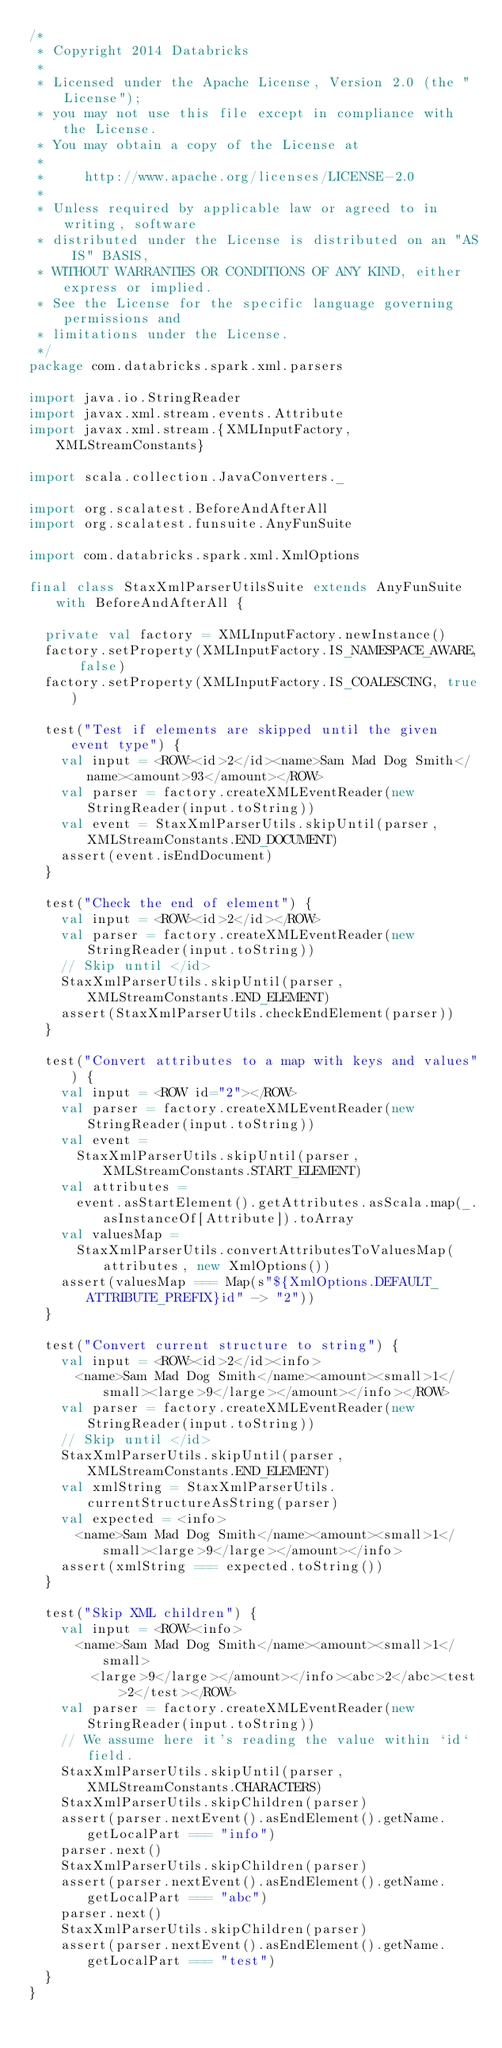Convert code to text. <code><loc_0><loc_0><loc_500><loc_500><_Scala_>/*
 * Copyright 2014 Databricks
 *
 * Licensed under the Apache License, Version 2.0 (the "License");
 * you may not use this file except in compliance with the License.
 * You may obtain a copy of the License at
 *
 *     http://www.apache.org/licenses/LICENSE-2.0
 *
 * Unless required by applicable law or agreed to in writing, software
 * distributed under the License is distributed on an "AS IS" BASIS,
 * WITHOUT WARRANTIES OR CONDITIONS OF ANY KIND, either express or implied.
 * See the License for the specific language governing permissions and
 * limitations under the License.
 */
package com.databricks.spark.xml.parsers

import java.io.StringReader
import javax.xml.stream.events.Attribute
import javax.xml.stream.{XMLInputFactory, XMLStreamConstants}

import scala.collection.JavaConverters._

import org.scalatest.BeforeAndAfterAll
import org.scalatest.funsuite.AnyFunSuite

import com.databricks.spark.xml.XmlOptions

final class StaxXmlParserUtilsSuite extends AnyFunSuite with BeforeAndAfterAll {

  private val factory = XMLInputFactory.newInstance()
  factory.setProperty(XMLInputFactory.IS_NAMESPACE_AWARE, false)
  factory.setProperty(XMLInputFactory.IS_COALESCING, true)

  test("Test if elements are skipped until the given event type") {
    val input = <ROW><id>2</id><name>Sam Mad Dog Smith</name><amount>93</amount></ROW>
    val parser = factory.createXMLEventReader(new StringReader(input.toString))
    val event = StaxXmlParserUtils.skipUntil(parser, XMLStreamConstants.END_DOCUMENT)
    assert(event.isEndDocument)
  }

  test("Check the end of element") {
    val input = <ROW><id>2</id></ROW>
    val parser = factory.createXMLEventReader(new StringReader(input.toString))
    // Skip until </id>
    StaxXmlParserUtils.skipUntil(parser, XMLStreamConstants.END_ELEMENT)
    assert(StaxXmlParserUtils.checkEndElement(parser))
  }

  test("Convert attributes to a map with keys and values") {
    val input = <ROW id="2"></ROW>
    val parser = factory.createXMLEventReader(new StringReader(input.toString))
    val event =
      StaxXmlParserUtils.skipUntil(parser, XMLStreamConstants.START_ELEMENT)
    val attributes =
      event.asStartElement().getAttributes.asScala.map(_.asInstanceOf[Attribute]).toArray
    val valuesMap =
      StaxXmlParserUtils.convertAttributesToValuesMap(attributes, new XmlOptions())
    assert(valuesMap === Map(s"${XmlOptions.DEFAULT_ATTRIBUTE_PREFIX}id" -> "2"))
  }

  test("Convert current structure to string") {
    val input = <ROW><id>2</id><info>
      <name>Sam Mad Dog Smith</name><amount><small>1</small><large>9</large></amount></info></ROW>
    val parser = factory.createXMLEventReader(new StringReader(input.toString))
    // Skip until </id>
    StaxXmlParserUtils.skipUntil(parser, XMLStreamConstants.END_ELEMENT)
    val xmlString = StaxXmlParserUtils.currentStructureAsString(parser)
    val expected = <info>
      <name>Sam Mad Dog Smith</name><amount><small>1</small><large>9</large></amount></info>
    assert(xmlString === expected.toString())
  }

  test("Skip XML children") {
    val input = <ROW><info>
      <name>Sam Mad Dog Smith</name><amount><small>1</small>
        <large>9</large></amount></info><abc>2</abc><test>2</test></ROW>
    val parser = factory.createXMLEventReader(new StringReader(input.toString))
    // We assume here it's reading the value within `id` field.
    StaxXmlParserUtils.skipUntil(parser, XMLStreamConstants.CHARACTERS)
    StaxXmlParserUtils.skipChildren(parser)
    assert(parser.nextEvent().asEndElement().getName.getLocalPart === "info")
    parser.next()
    StaxXmlParserUtils.skipChildren(parser)
    assert(parser.nextEvent().asEndElement().getName.getLocalPart === "abc")
    parser.next()
    StaxXmlParserUtils.skipChildren(parser)
    assert(parser.nextEvent().asEndElement().getName.getLocalPart === "test")
  }
}
</code> 